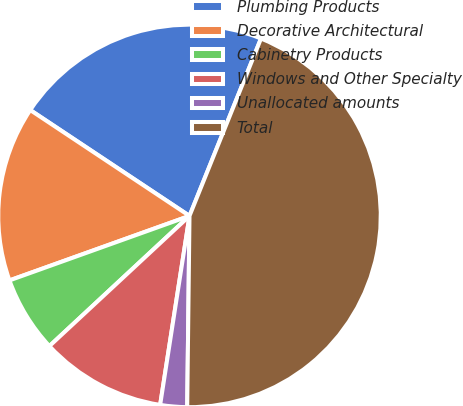<chart> <loc_0><loc_0><loc_500><loc_500><pie_chart><fcel>Plumbing Products<fcel>Decorative Architectural<fcel>Cabinetry Products<fcel>Windows and Other Specialty<fcel>Unallocated amounts<fcel>Total<nl><fcel>21.76%<fcel>14.81%<fcel>6.44%<fcel>10.63%<fcel>2.26%<fcel>44.09%<nl></chart> 